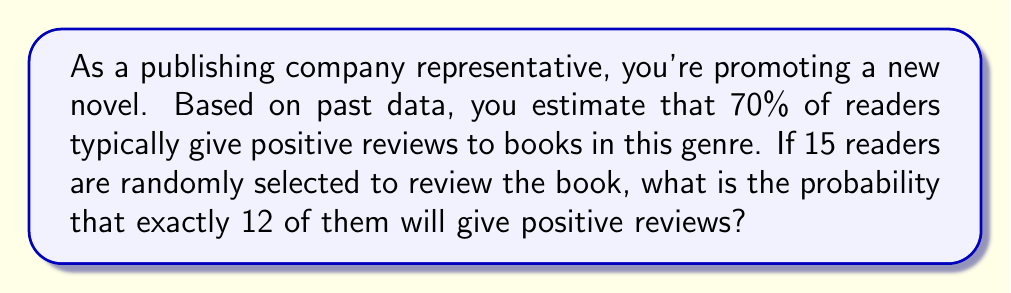What is the answer to this math problem? To solve this problem, we'll use the binomial distribution formula:

$$P(X=k) = \binom{n}{k} p^k (1-p)^{n-k}$$

Where:
$n$ = number of trials (readers)
$k$ = number of successes (positive reviews)
$p$ = probability of success on each trial

Given:
$n = 15$
$k = 12$
$p = 0.70$

Step 1: Calculate the binomial coefficient
$$\binom{15}{12} = \frac{15!}{12!(15-12)!} = \frac{15!}{12!3!} = 455$$

Step 2: Calculate $p^k$
$$0.70^{12} \approx 0.0138$$

Step 3: Calculate $(1-p)^{n-k}$
$$(1-0.70)^{15-12} = 0.30^3 \approx 0.027$$

Step 4: Multiply the results from steps 1, 2, and 3
$$455 \times 0.0138 \times 0.027 \approx 0.1693$$

Therefore, the probability of exactly 12 out of 15 randomly selected readers giving positive reviews is approximately 0.1693 or 16.93%.
Answer: 0.1693 